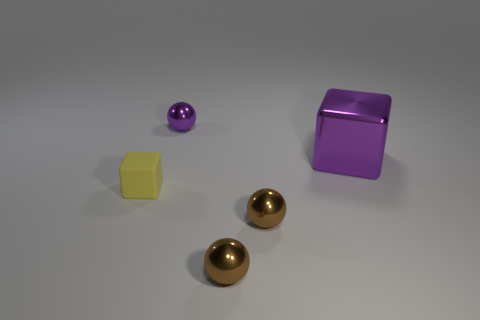Subtract 1 spheres. How many spheres are left? 2 Subtract all tiny brown metallic balls. How many balls are left? 1 Add 5 small yellow rubber objects. How many objects exist? 10 Subtract all blocks. How many objects are left? 3 Subtract all yellow things. Subtract all tiny purple metallic balls. How many objects are left? 3 Add 4 purple metallic objects. How many purple metallic objects are left? 6 Add 2 large red matte cylinders. How many large red matte cylinders exist? 2 Subtract 0 yellow spheres. How many objects are left? 5 